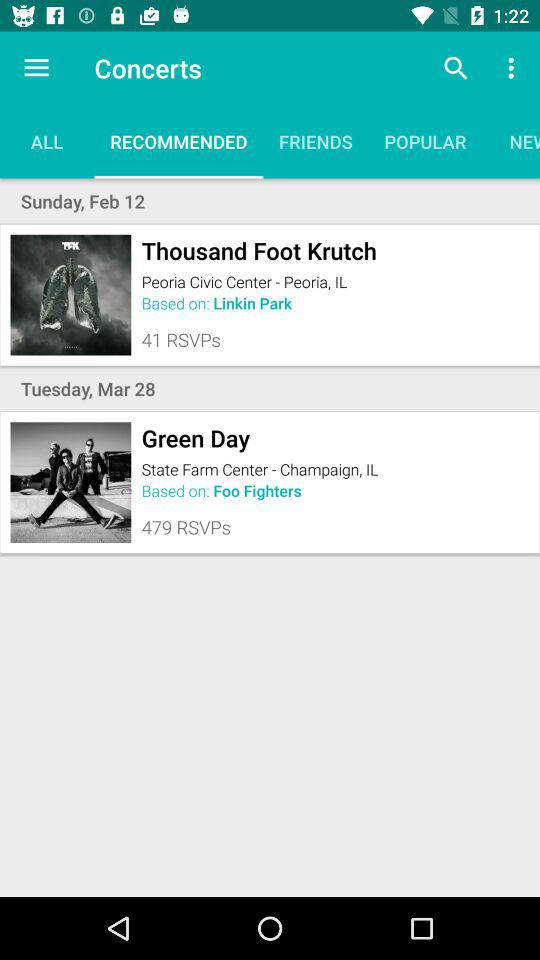What is the venue of the concert where "Thousand Foot Krutch" will be performing? The venue is the Peoria Civic Center - Peoria, IL. 